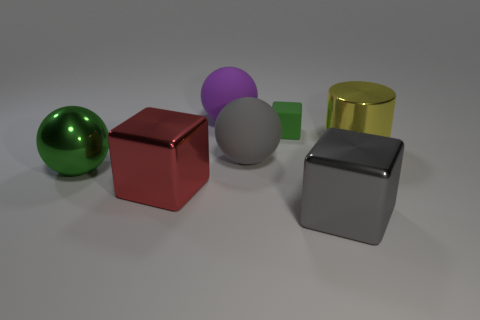Add 2 gray balls. How many objects exist? 9 Subtract all balls. How many objects are left? 4 Subtract all gray shiny spheres. Subtract all yellow metal things. How many objects are left? 6 Add 3 big shiny cubes. How many big shiny cubes are left? 5 Add 7 green matte blocks. How many green matte blocks exist? 8 Subtract 0 blue cylinders. How many objects are left? 7 